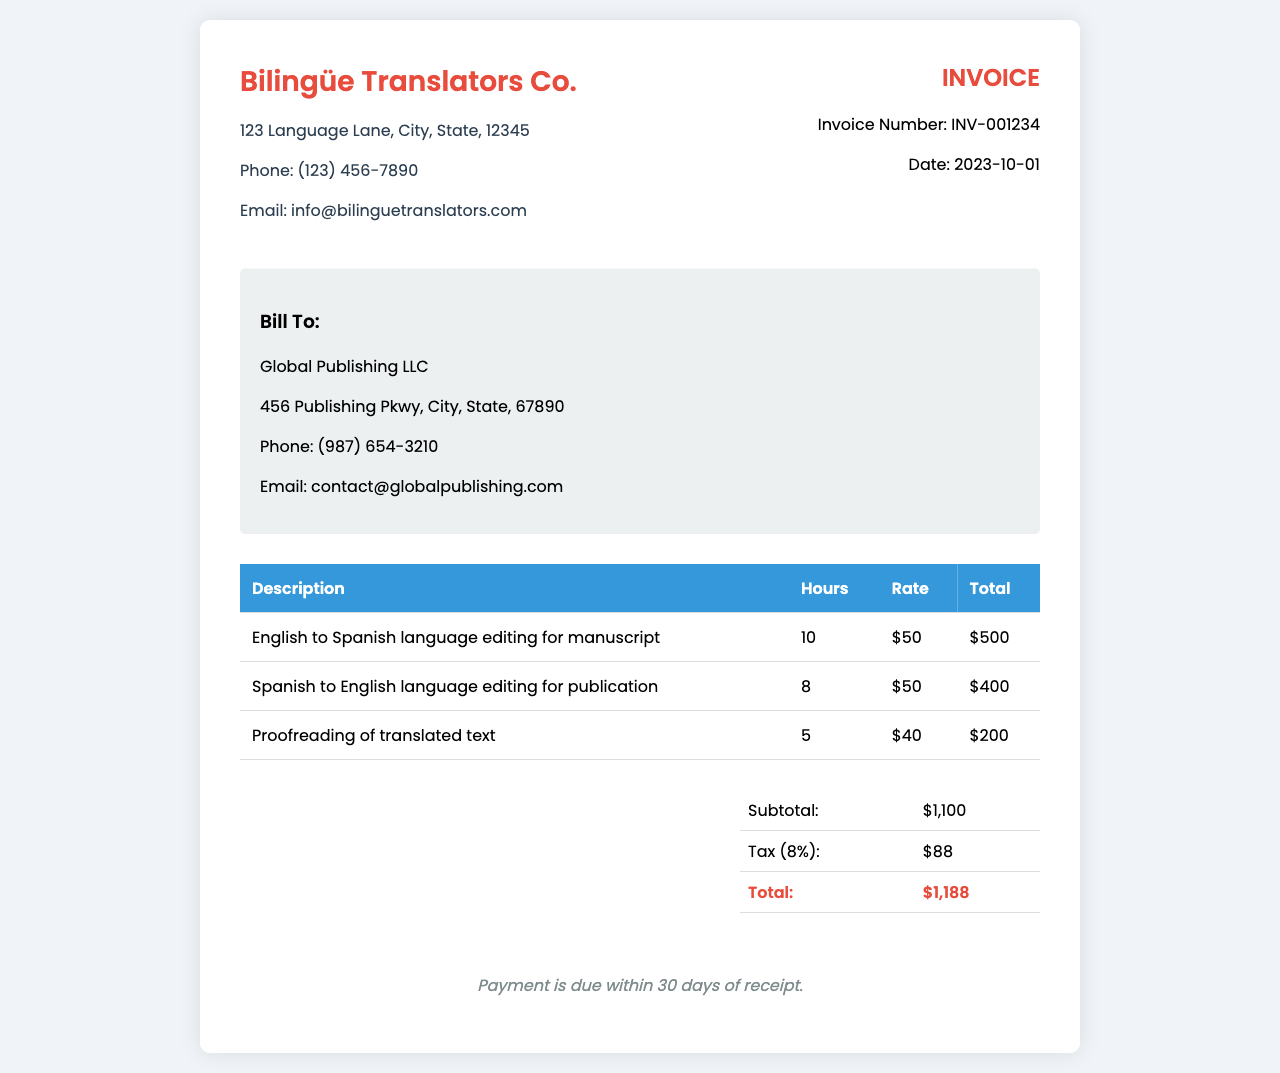What is the invoice number? The invoice number is listed in the document under the invoice details section.
Answer: INV-001234 What date is the invoice issued? The date of the invoice can be found next to the invoice number in the invoice details section.
Answer: 2023-10-01 Who is the client? The client's name is provided in the "Bill To" section of the document.
Answer: Global Publishing LLC What is the subtotal amount? The subtotal amount is detailed in the summary table towards the end of the document.
Answer: $1,100 How many hours were spent on proofreading? The number of hours for proofreading can be found in the breakdown of services table.
Answer: 5 What is the tax percentage applied? The tax percentage can be inferred from the tax description in the summary table.
Answer: 8% What service was provided for the least hours? This can be determined by comparing the hours listed for each service in the breakdown table.
Answer: Proofreading of translated text When is the payment due? The payment terms specify when the payment is required; this is mentioned at the bottom of the document.
Answer: within 30 days of receipt What is the total amount due? The total amount due is given in the summary section of the invoice.
Answer: $1,188 